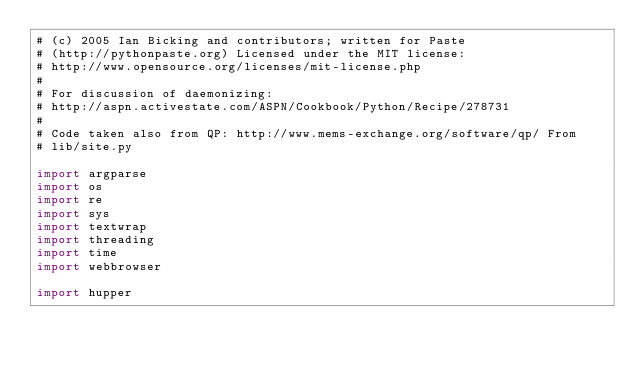<code> <loc_0><loc_0><loc_500><loc_500><_Python_># (c) 2005 Ian Bicking and contributors; written for Paste
# (http://pythonpaste.org) Licensed under the MIT license:
# http://www.opensource.org/licenses/mit-license.php
#
# For discussion of daemonizing:
# http://aspn.activestate.com/ASPN/Cookbook/Python/Recipe/278731
#
# Code taken also from QP: http://www.mems-exchange.org/software/qp/ From
# lib/site.py

import argparse
import os
import re
import sys
import textwrap
import threading
import time
import webbrowser

import hupper
</code> 